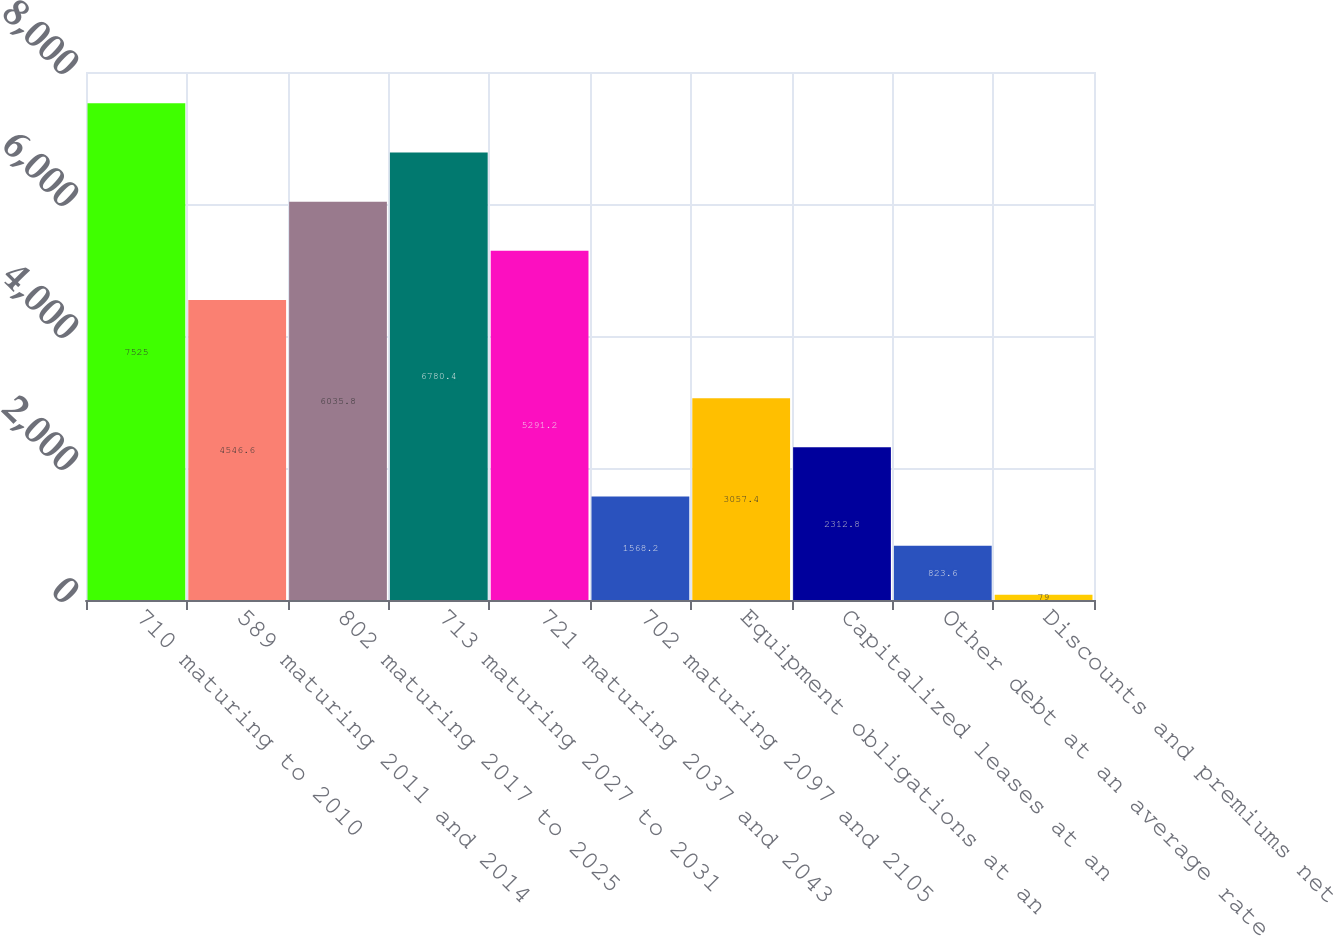<chart> <loc_0><loc_0><loc_500><loc_500><bar_chart><fcel>710 maturing to 2010<fcel>589 maturing 2011 and 2014<fcel>802 maturing 2017 to 2025<fcel>713 maturing 2027 to 2031<fcel>721 maturing 2037 and 2043<fcel>702 maturing 2097 and 2105<fcel>Equipment obligations at an<fcel>Capitalized leases at an<fcel>Other debt at an average rate<fcel>Discounts and premiums net<nl><fcel>7525<fcel>4546.6<fcel>6035.8<fcel>6780.4<fcel>5291.2<fcel>1568.2<fcel>3057.4<fcel>2312.8<fcel>823.6<fcel>79<nl></chart> 